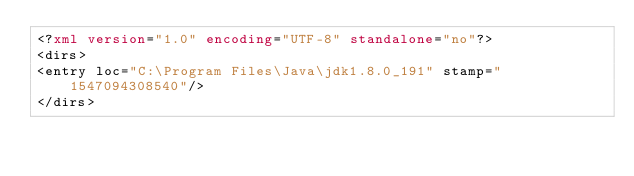<code> <loc_0><loc_0><loc_500><loc_500><_XML_><?xml version="1.0" encoding="UTF-8" standalone="no"?>
<dirs>
<entry loc="C:\Program Files\Java\jdk1.8.0_191" stamp="1547094308540"/>
</dirs>
</code> 